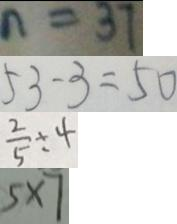<formula> <loc_0><loc_0><loc_500><loc_500>n = 3 7 
 5 3 - 3 = 5 0 
 \frac { 2 } { 5 } \div 4 
 5 \times 7</formula> 